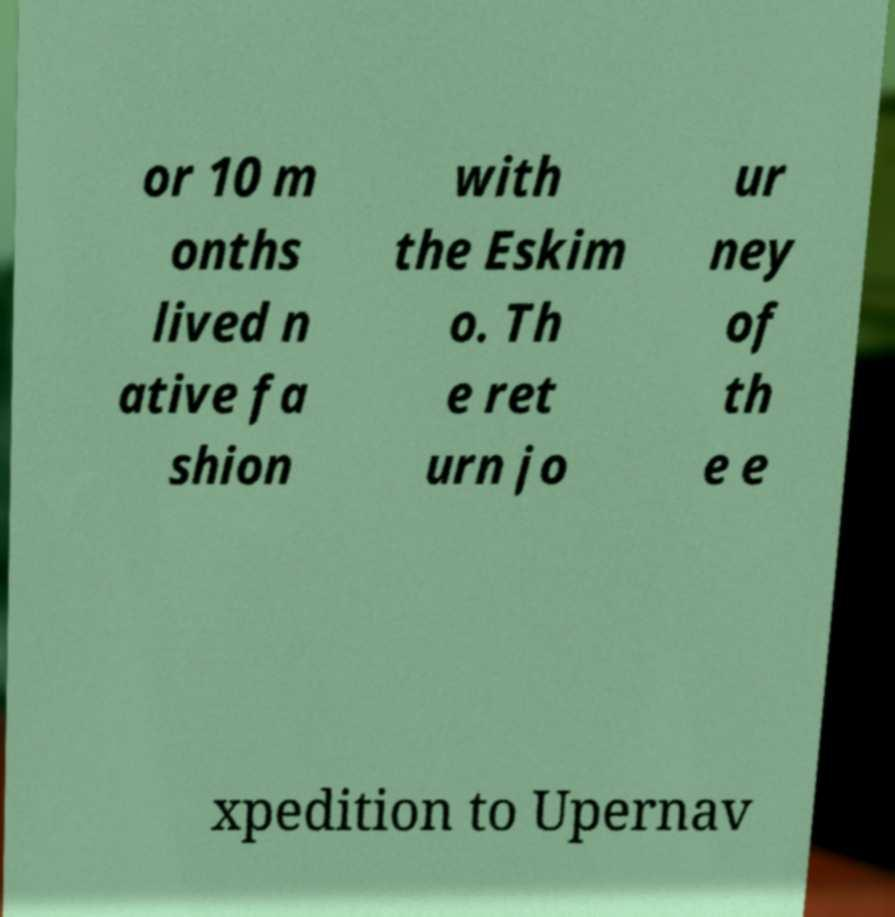For documentation purposes, I need the text within this image transcribed. Could you provide that? or 10 m onths lived n ative fa shion with the Eskim o. Th e ret urn jo ur ney of th e e xpedition to Upernav 